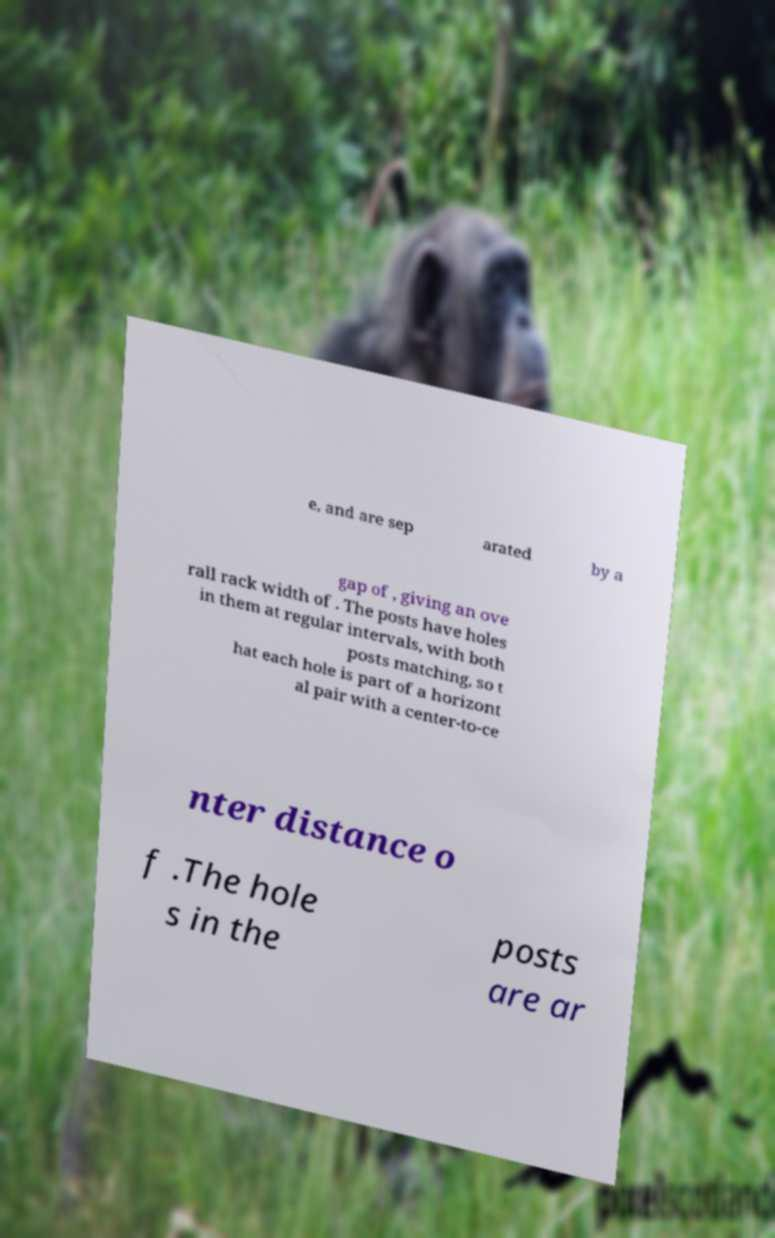Please read and relay the text visible in this image. What does it say? e, and are sep arated by a gap of , giving an ove rall rack width of . The posts have holes in them at regular intervals, with both posts matching, so t hat each hole is part of a horizont al pair with a center-to-ce nter distance o f .The hole s in the posts are ar 